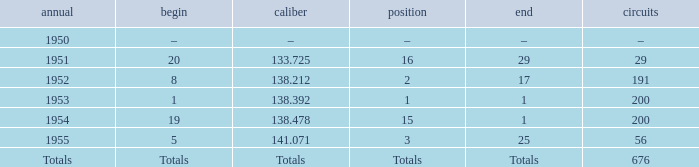How many laps does the one ranked 16 have? 29.0. Give me the full table as a dictionary. {'header': ['annual', 'begin', 'caliber', 'position', 'end', 'circuits'], 'rows': [['1950', '–', '–', '–', '–', '–'], ['1951', '20', '133.725', '16', '29', '29'], ['1952', '8', '138.212', '2', '17', '191'], ['1953', '1', '138.392', '1', '1', '200'], ['1954', '19', '138.478', '15', '1', '200'], ['1955', '5', '141.071', '3', '25', '56'], ['Totals', 'Totals', 'Totals', 'Totals', 'Totals', '676']]} 